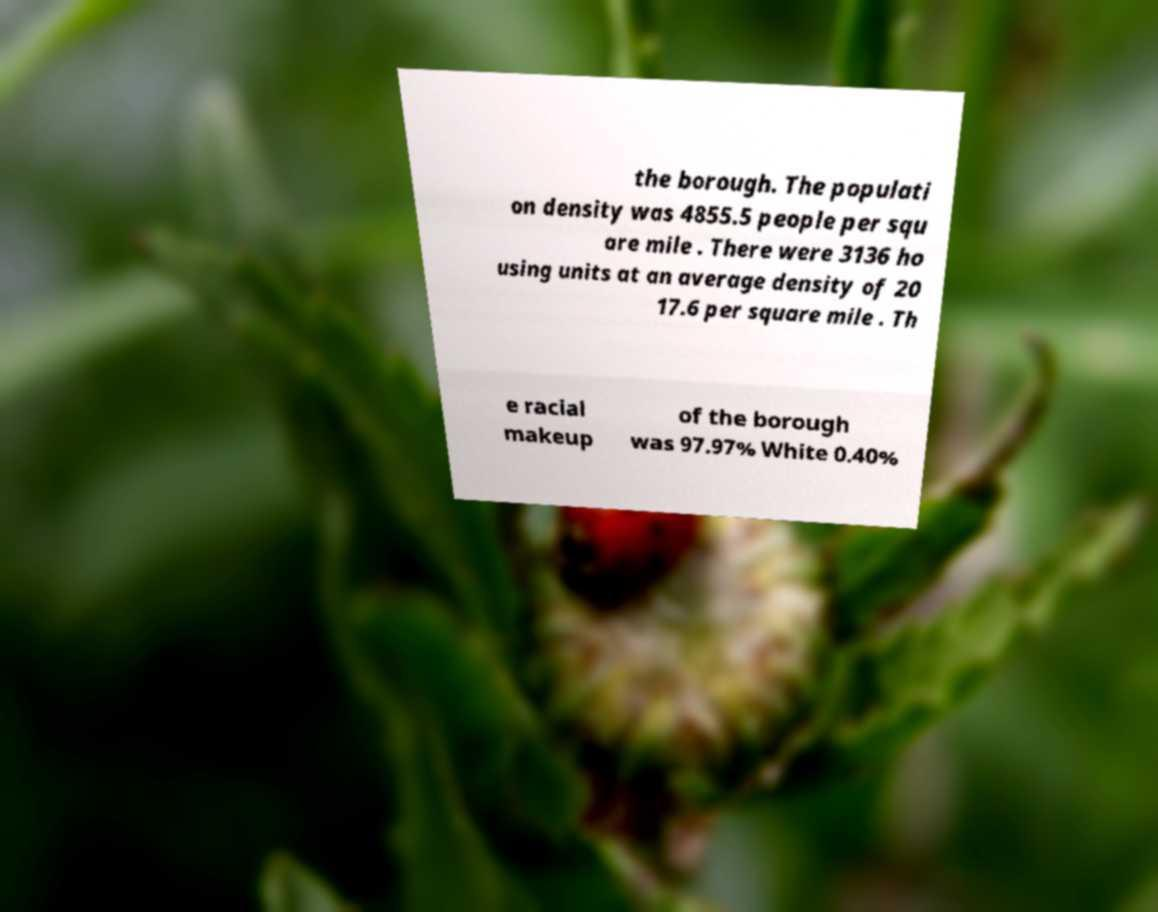There's text embedded in this image that I need extracted. Can you transcribe it verbatim? the borough. The populati on density was 4855.5 people per squ are mile . There were 3136 ho using units at an average density of 20 17.6 per square mile . Th e racial makeup of the borough was 97.97% White 0.40% 